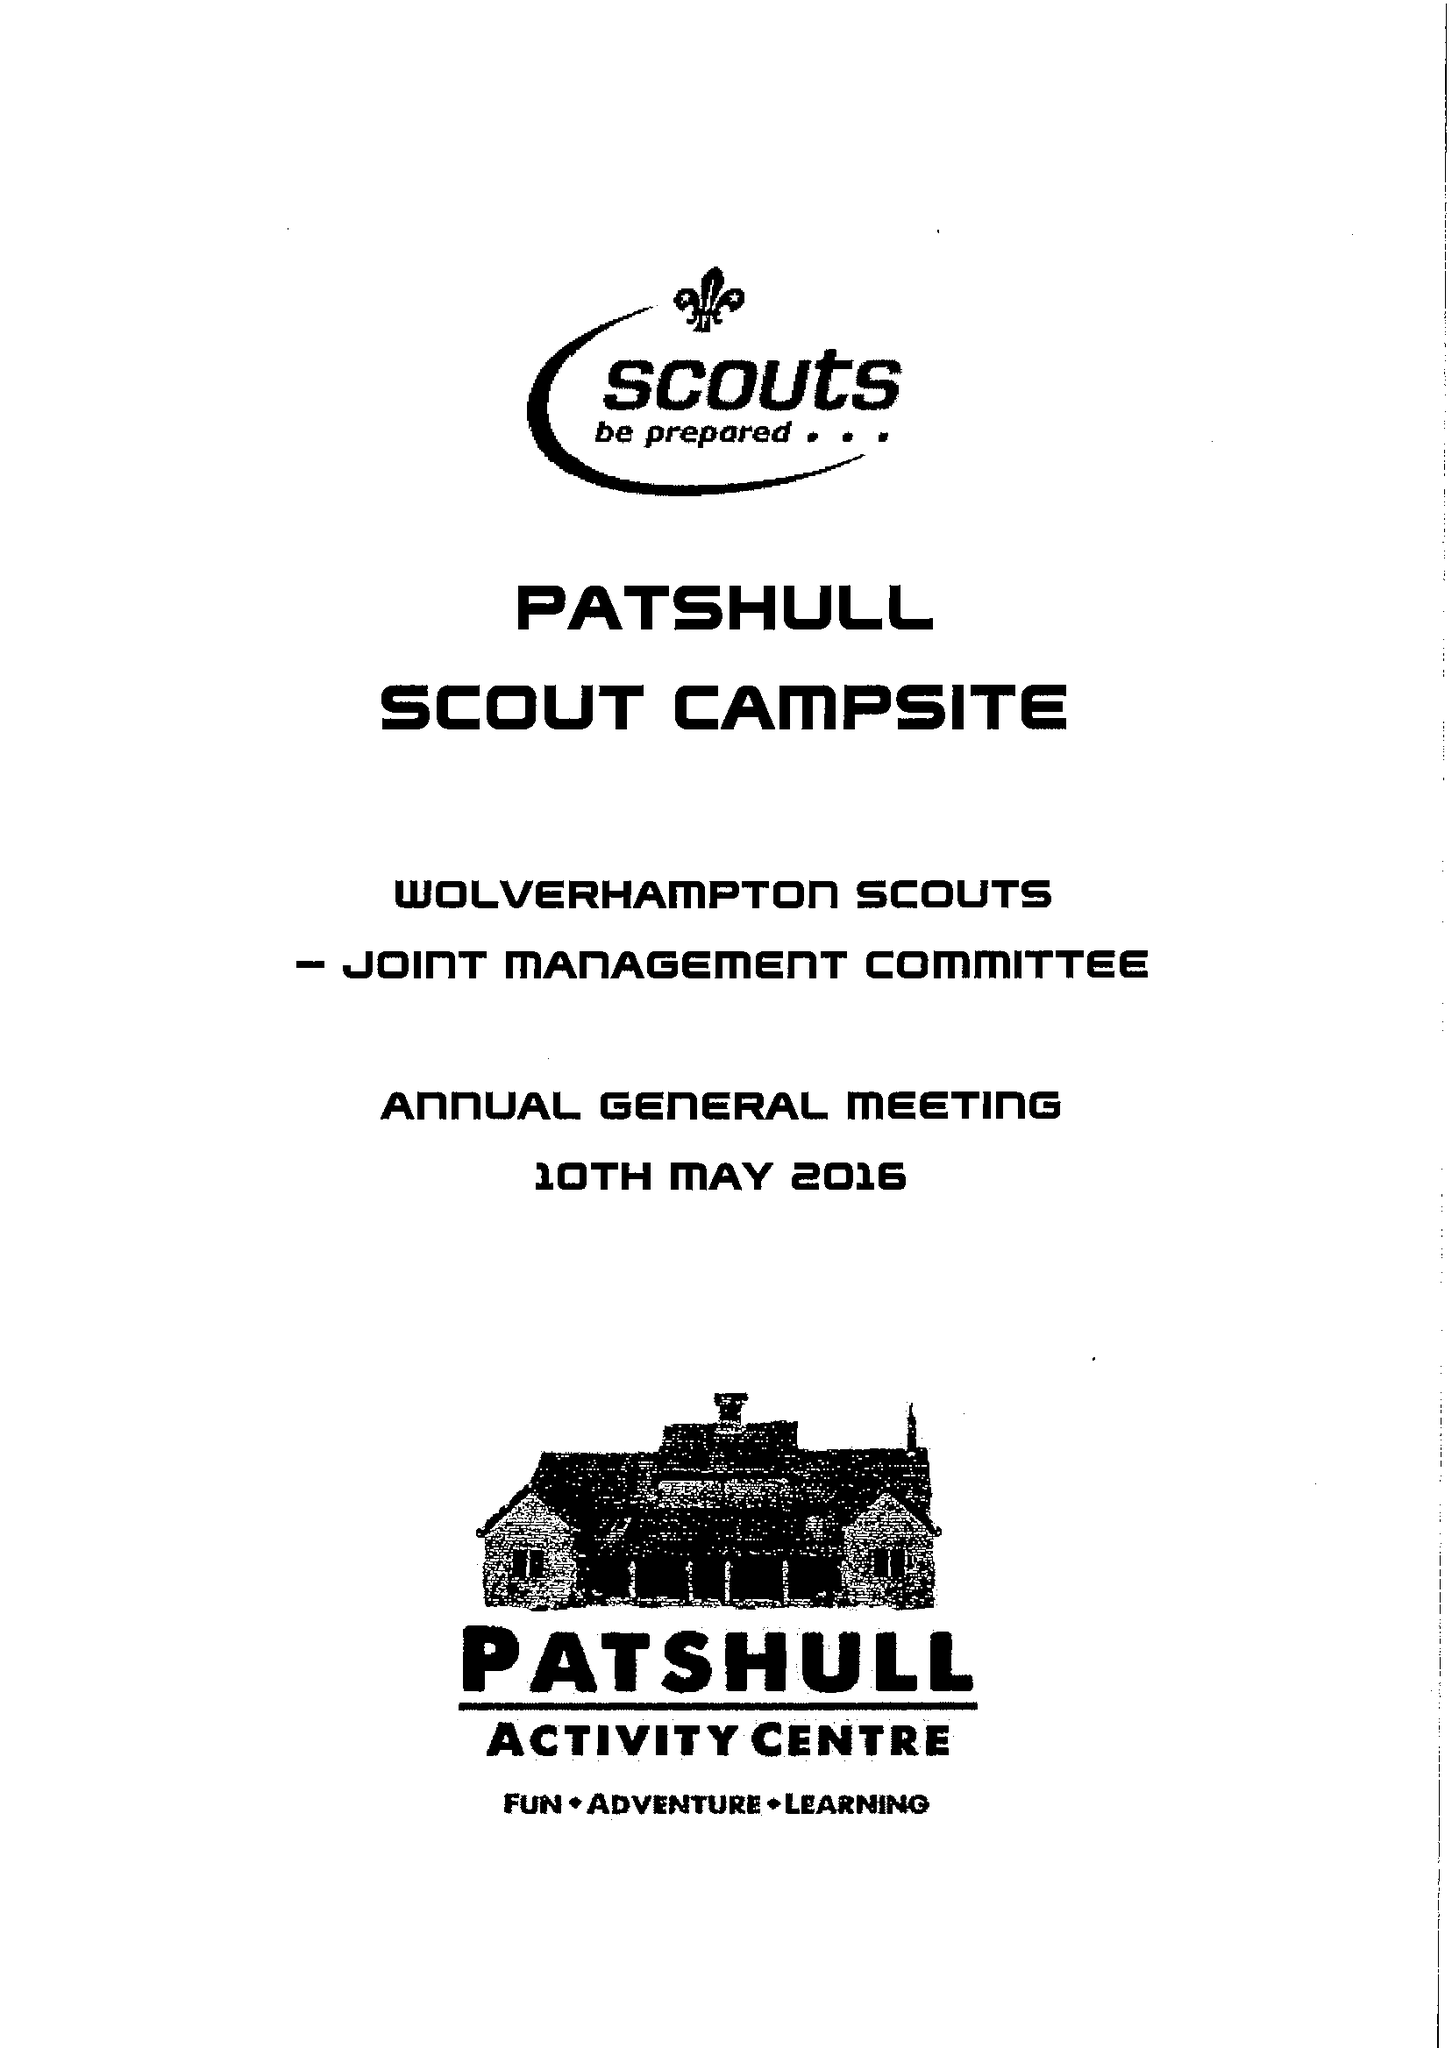What is the value for the address__post_town?
Answer the question using a single word or phrase. WOLVERHAMPTON 